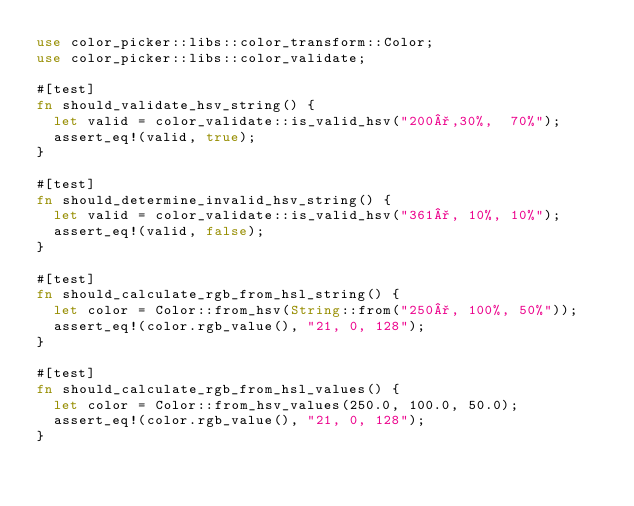<code> <loc_0><loc_0><loc_500><loc_500><_Rust_>use color_picker::libs::color_transform::Color;
use color_picker::libs::color_validate;

#[test]
fn should_validate_hsv_string() {
  let valid = color_validate::is_valid_hsv("200°,30%,  70%");
  assert_eq!(valid, true);
}

#[test]
fn should_determine_invalid_hsv_string() {
  let valid = color_validate::is_valid_hsv("361°, 10%, 10%");
  assert_eq!(valid, false);
}

#[test]
fn should_calculate_rgb_from_hsl_string() {
  let color = Color::from_hsv(String::from("250°, 100%, 50%"));
  assert_eq!(color.rgb_value(), "21, 0, 128");
}

#[test]
fn should_calculate_rgb_from_hsl_values() {
  let color = Color::from_hsv_values(250.0, 100.0, 50.0);
  assert_eq!(color.rgb_value(), "21, 0, 128");
}
</code> 